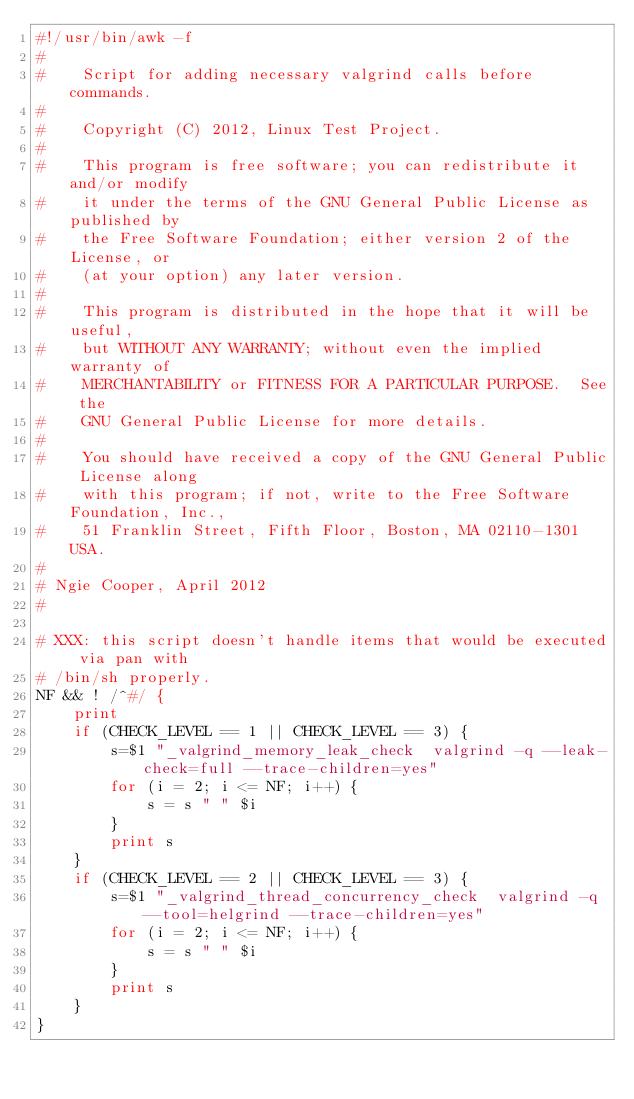Convert code to text. <code><loc_0><loc_0><loc_500><loc_500><_Awk_>#!/usr/bin/awk -f
#
#    Script for adding necessary valgrind calls before commands.
#
#    Copyright (C) 2012, Linux Test Project.
#
#    This program is free software; you can redistribute it and/or modify
#    it under the terms of the GNU General Public License as published by
#    the Free Software Foundation; either version 2 of the License, or
#    (at your option) any later version.
#
#    This program is distributed in the hope that it will be useful,
#    but WITHOUT ANY WARRANTY; without even the implied warranty of
#    MERCHANTABILITY or FITNESS FOR A PARTICULAR PURPOSE.  See the
#    GNU General Public License for more details.
#
#    You should have received a copy of the GNU General Public License along
#    with this program; if not, write to the Free Software Foundation, Inc.,
#    51 Franklin Street, Fifth Floor, Boston, MA 02110-1301 USA.
#
# Ngie Cooper, April 2012
#

# XXX: this script doesn't handle items that would be executed via pan with
# /bin/sh properly.
NF && ! /^#/ {
	print
	if (CHECK_LEVEL == 1 || CHECK_LEVEL == 3) {
		s=$1 "_valgrind_memory_leak_check  valgrind -q --leak-check=full --trace-children=yes"
		for (i = 2; i <= NF; i++) {
			s = s " " $i
		}
		print s
	}
	if (CHECK_LEVEL == 2 || CHECK_LEVEL == 3) {
		s=$1 "_valgrind_thread_concurrency_check  valgrind -q --tool=helgrind --trace-children=yes"
		for (i = 2; i <= NF; i++) {
			s = s " " $i
		}
		print s
	}
}
</code> 